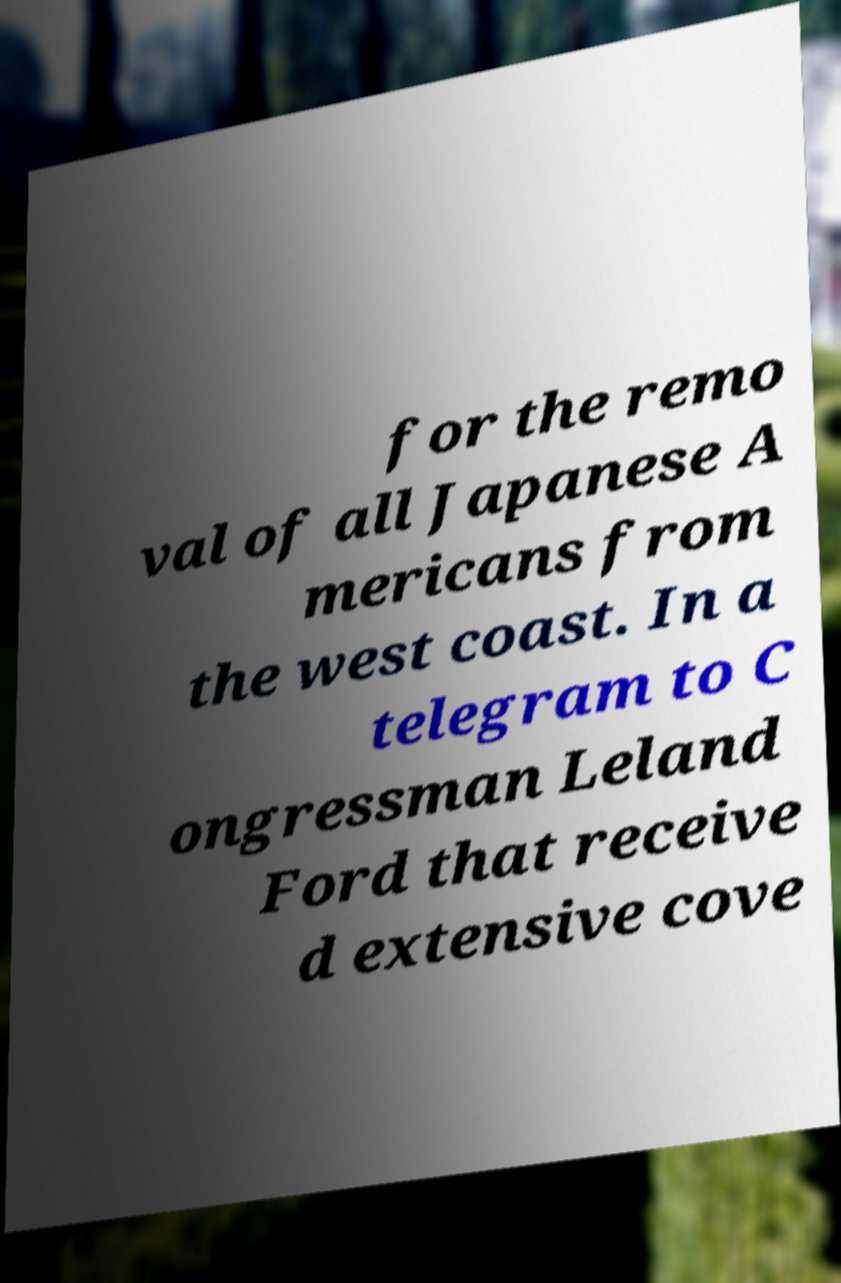Please identify and transcribe the text found in this image. for the remo val of all Japanese A mericans from the west coast. In a telegram to C ongressman Leland Ford that receive d extensive cove 